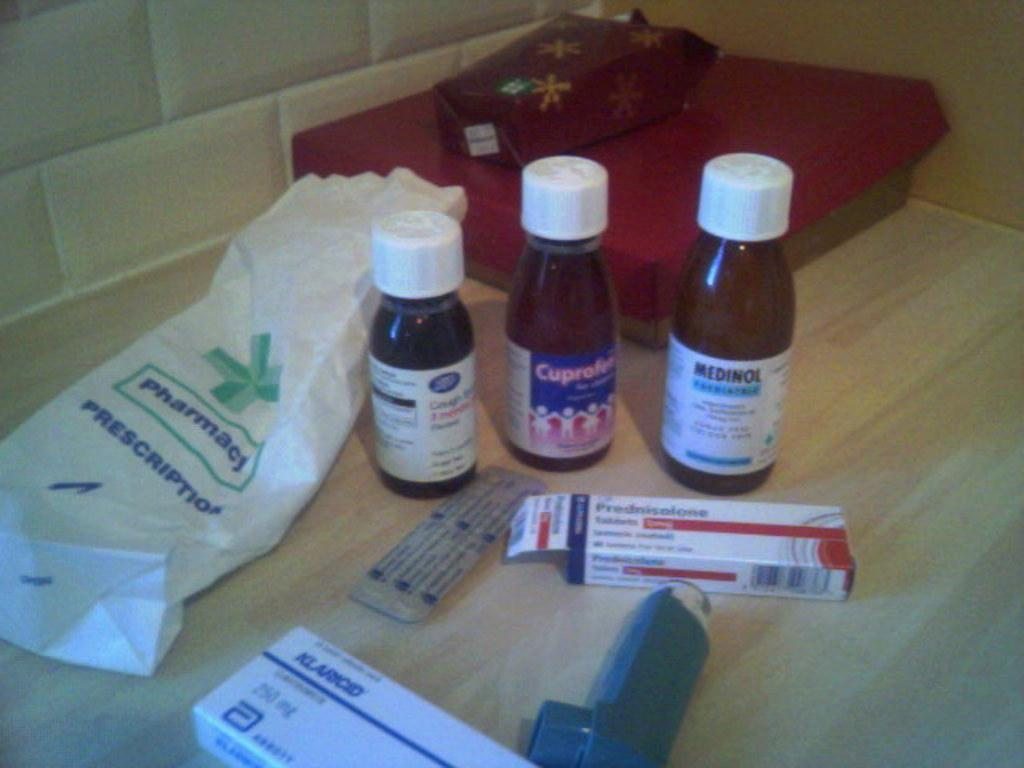<image>
Describe the image concisely. medicine bottles standing in front of a bag that says 'pharmacy' on it 